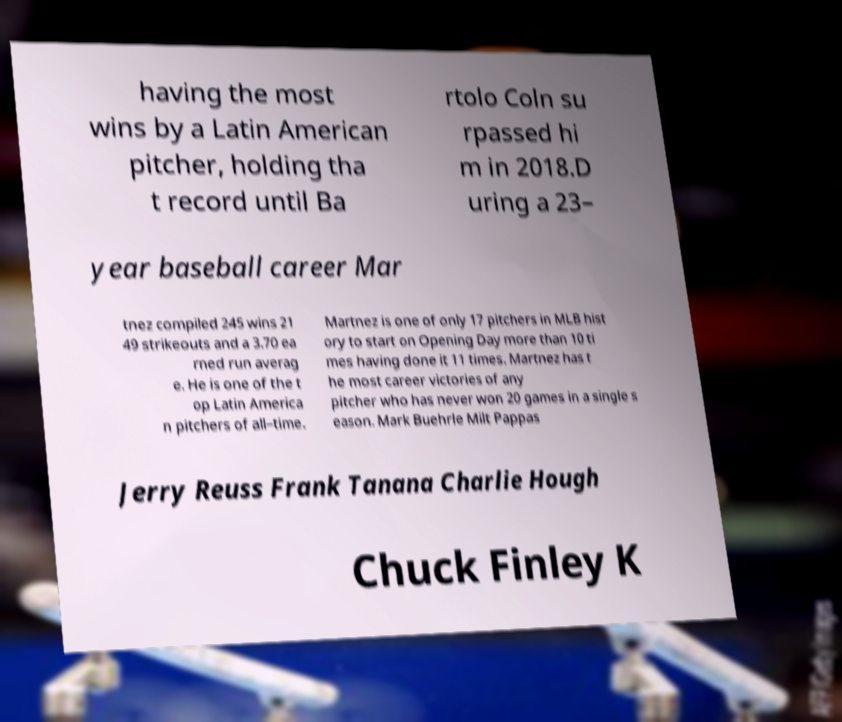There's text embedded in this image that I need extracted. Can you transcribe it verbatim? having the most wins by a Latin American pitcher, holding tha t record until Ba rtolo Coln su rpassed hi m in 2018.D uring a 23– year baseball career Mar tnez compiled 245 wins 21 49 strikeouts and a 3.70 ea rned run averag e. He is one of the t op Latin America n pitchers of all–time. Martnez is one of only 17 pitchers in MLB hist ory to start on Opening Day more than 10 ti mes having done it 11 times. Martnez has t he most career victories of any pitcher who has never won 20 games in a single s eason. Mark Buehrle Milt Pappas Jerry Reuss Frank Tanana Charlie Hough Chuck Finley K 